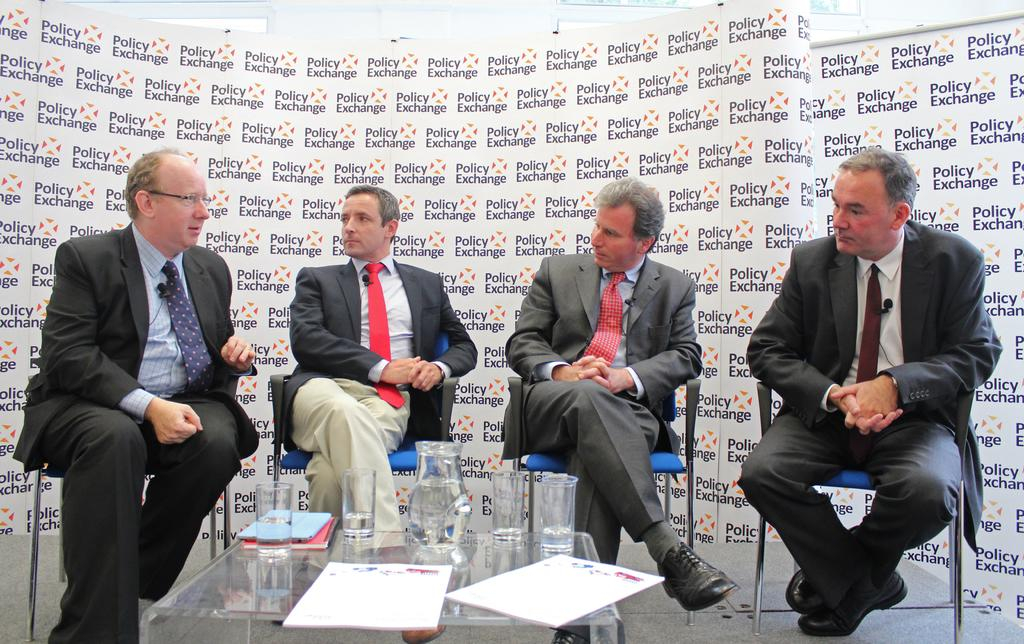What are the people in the image doing? The people in the image are sitting on chairs. What is present on the table in the image? There is a jug and glasses on the table. Can you describe the table in the image? The table is a flat surface with objects on it, including a jug and glasses. What type of throat medicine is present on the table in the image? There is no throat medicine present on the table in the image. Is there a person in a prison depicted in the image? There is no prison or person in a prison depicted in the image. 